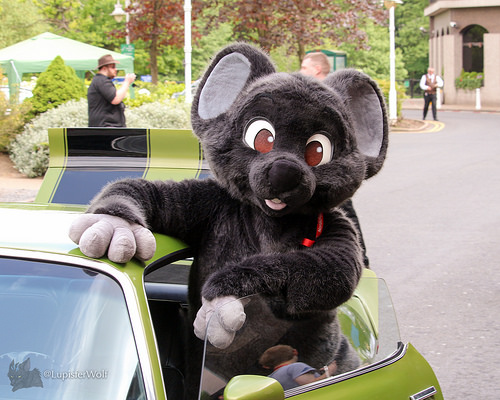<image>
Is there a man behind the car? Yes. From this viewpoint, the man is positioned behind the car, with the car partially or fully occluding the man. Is the mouse behind the car door? Yes. From this viewpoint, the mouse is positioned behind the car door, with the car door partially or fully occluding the mouse. 